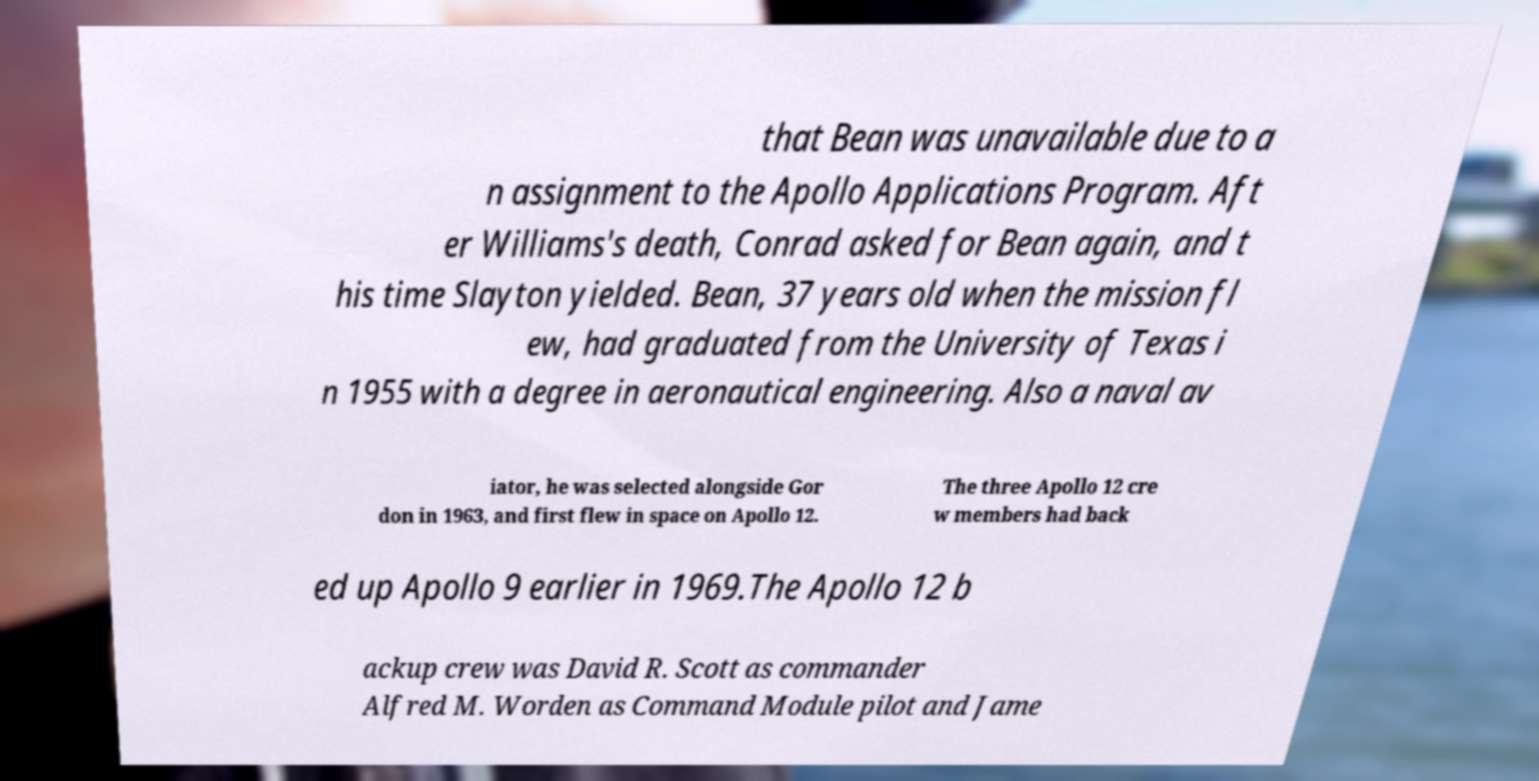Please read and relay the text visible in this image. What does it say? that Bean was unavailable due to a n assignment to the Apollo Applications Program. Aft er Williams's death, Conrad asked for Bean again, and t his time Slayton yielded. Bean, 37 years old when the mission fl ew, had graduated from the University of Texas i n 1955 with a degree in aeronautical engineering. Also a naval av iator, he was selected alongside Gor don in 1963, and first flew in space on Apollo 12. The three Apollo 12 cre w members had back ed up Apollo 9 earlier in 1969.The Apollo 12 b ackup crew was David R. Scott as commander Alfred M. Worden as Command Module pilot and Jame 